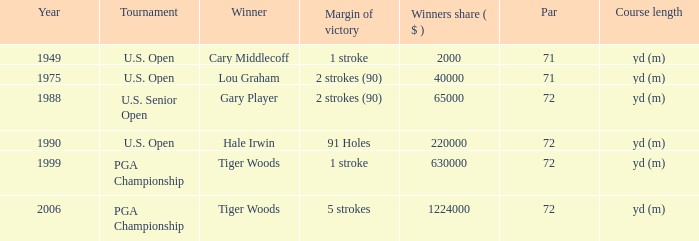When cary middlecoff emerges victorious, how many pars are present? 1.0. 